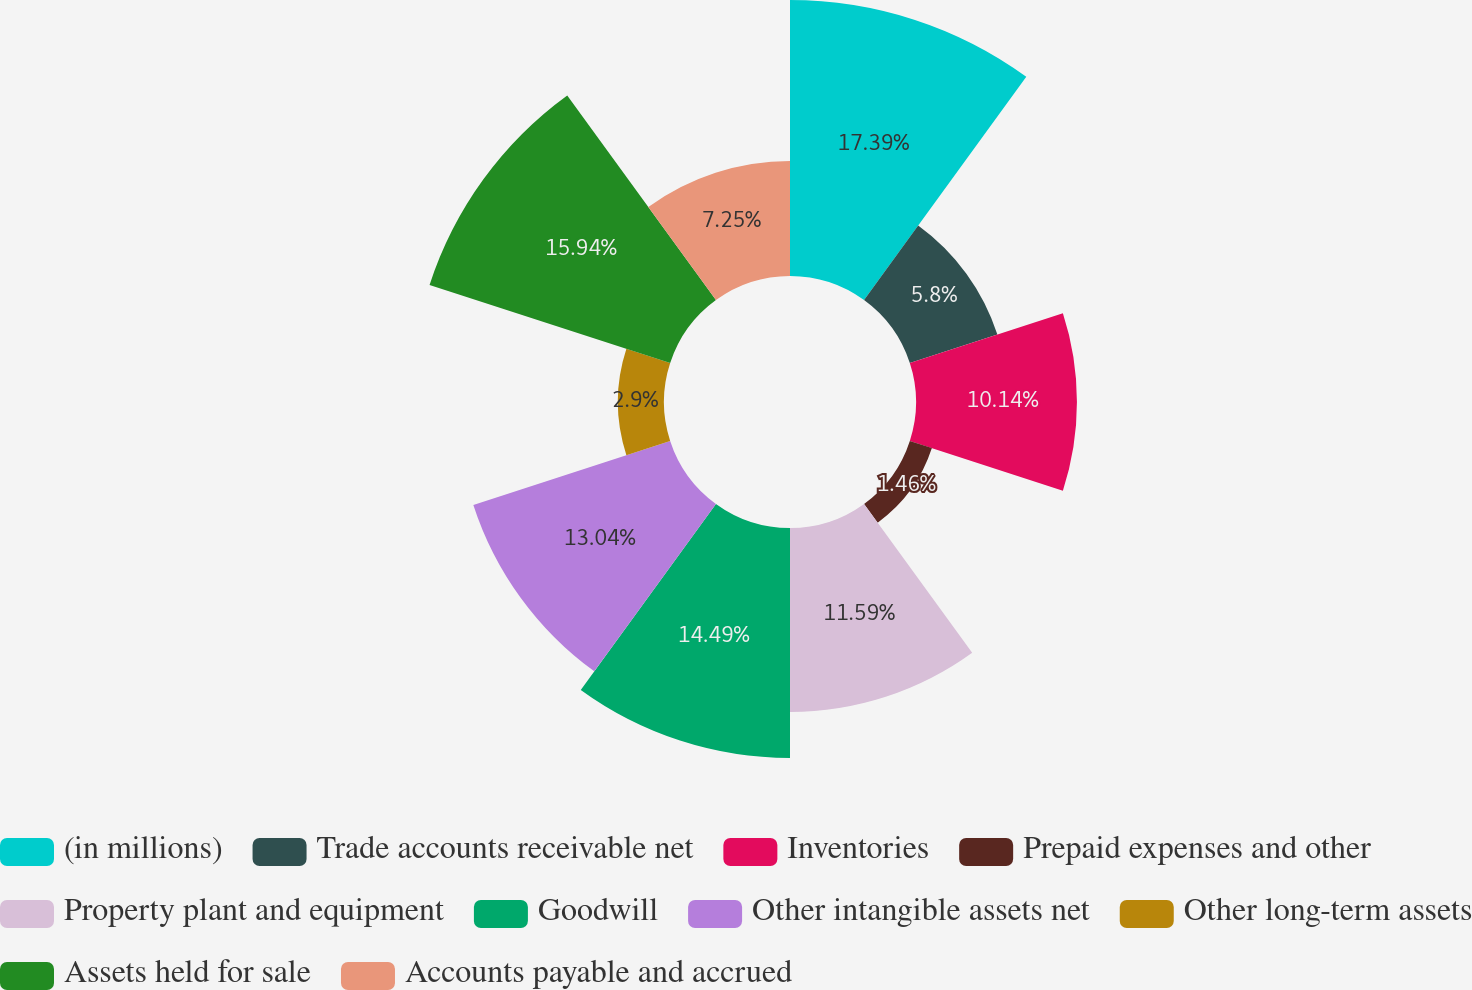Convert chart to OTSL. <chart><loc_0><loc_0><loc_500><loc_500><pie_chart><fcel>(in millions)<fcel>Trade accounts receivable net<fcel>Inventories<fcel>Prepaid expenses and other<fcel>Property plant and equipment<fcel>Goodwill<fcel>Other intangible assets net<fcel>Other long-term assets<fcel>Assets held for sale<fcel>Accounts payable and accrued<nl><fcel>17.39%<fcel>5.8%<fcel>10.14%<fcel>1.46%<fcel>11.59%<fcel>14.49%<fcel>13.04%<fcel>2.9%<fcel>15.94%<fcel>7.25%<nl></chart> 